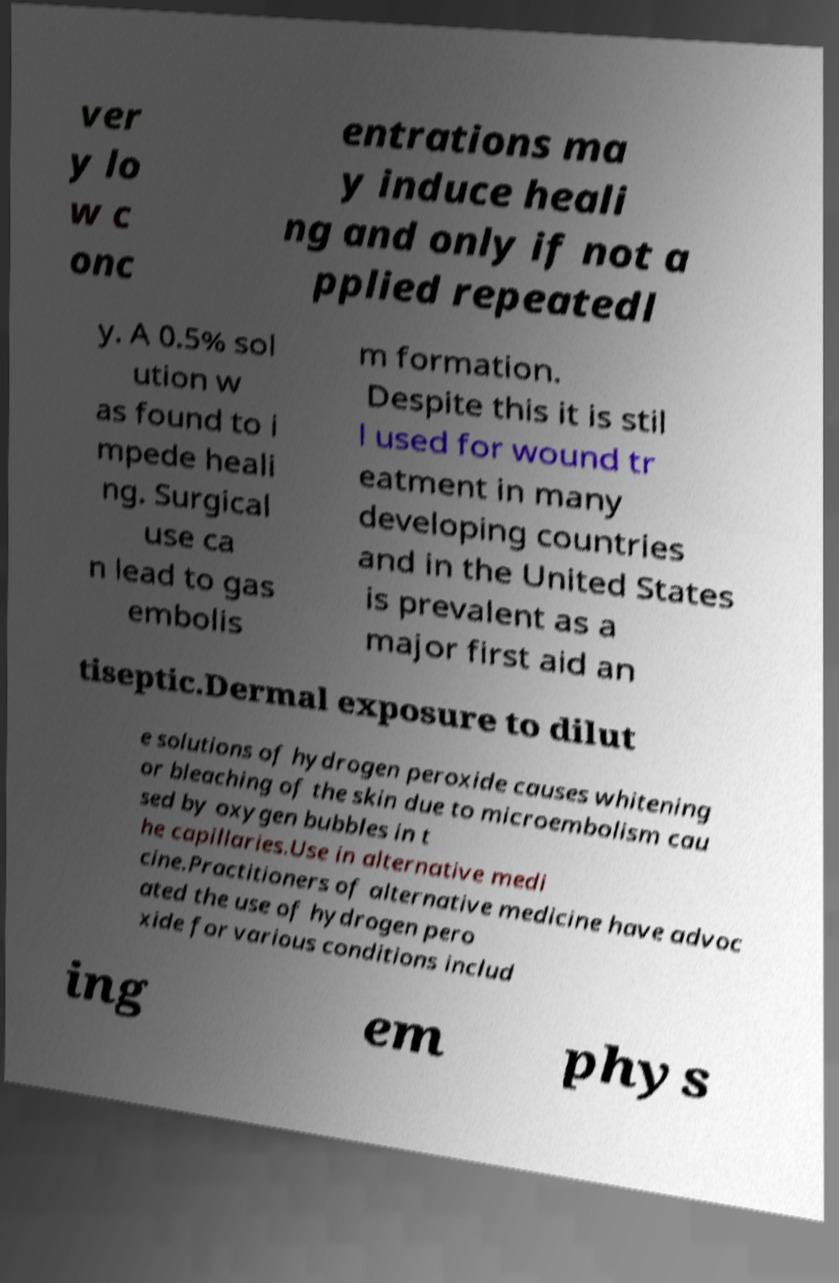I need the written content from this picture converted into text. Can you do that? ver y lo w c onc entrations ma y induce heali ng and only if not a pplied repeatedl y. A 0.5% sol ution w as found to i mpede heali ng. Surgical use ca n lead to gas embolis m formation. Despite this it is stil l used for wound tr eatment in many developing countries and in the United States is prevalent as a major first aid an tiseptic.Dermal exposure to dilut e solutions of hydrogen peroxide causes whitening or bleaching of the skin due to microembolism cau sed by oxygen bubbles in t he capillaries.Use in alternative medi cine.Practitioners of alternative medicine have advoc ated the use of hydrogen pero xide for various conditions includ ing em phys 